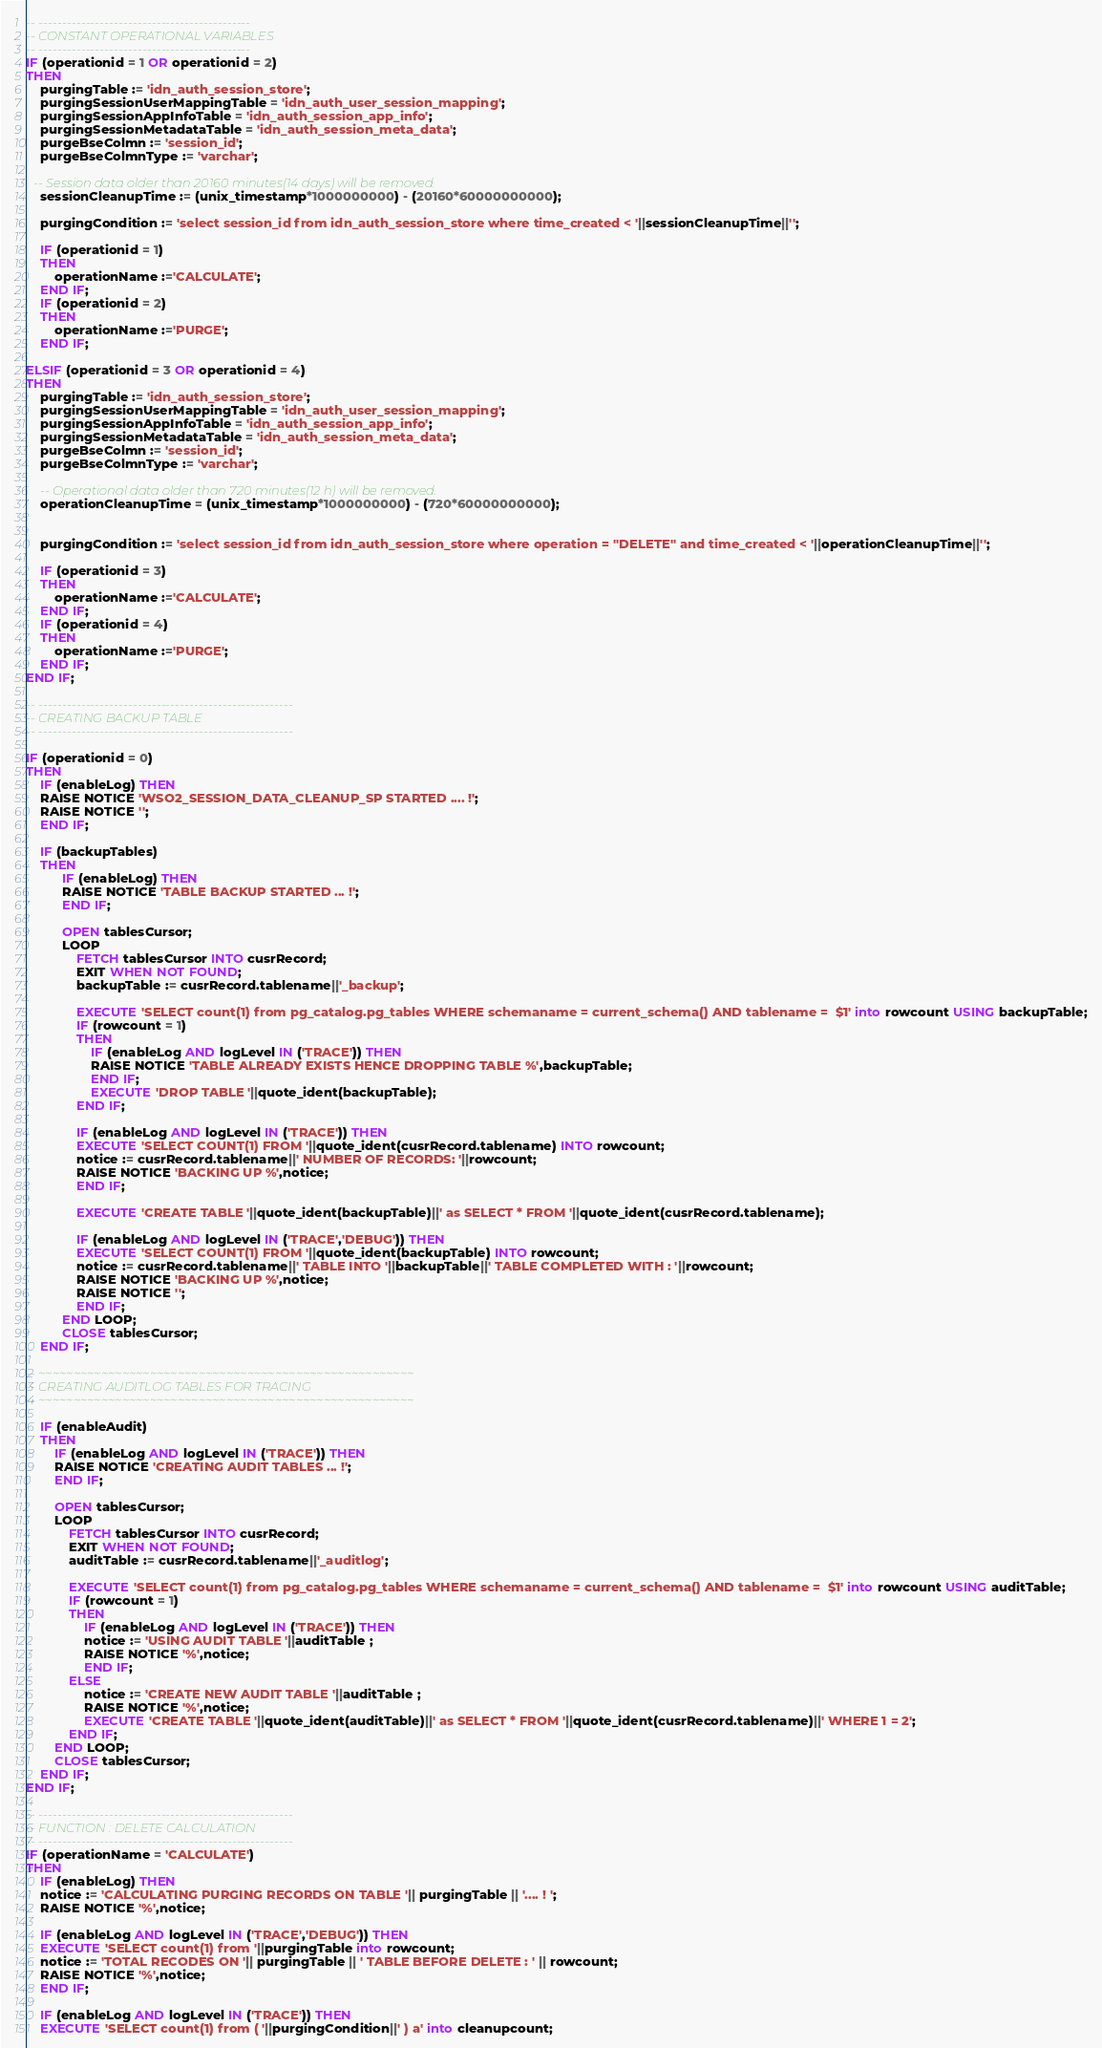<code> <loc_0><loc_0><loc_500><loc_500><_SQL_>
-- ---------------------------------------------
-- CONSTANT OPERATIONAL VARIABLES
-- ---------------------------------------------
IF (operationid = 1 OR operationid = 2)
THEN
    purgingTable := 'idn_auth_session_store';
    purgingSessionUserMappingTable = 'idn_auth_user_session_mapping';
    purgingSessionAppInfoTable = 'idn_auth_session_app_info';
    purgingSessionMetadataTable = 'idn_auth_session_meta_data';
    purgeBseColmn := 'session_id';
	purgeBseColmnType := 'varchar';

  -- Session data older than 20160 minutes(14 days) will be removed.
    sessionCleanupTime := (unix_timestamp*1000000000) - (20160*60000000000);

    purgingCondition := 'select session_id from idn_auth_session_store where time_created < '||sessionCleanupTime||'';

    IF (operationid = 1)
    THEN
        operationName :='CALCULATE';
    END IF;
    IF (operationid = 2)
    THEN
        operationName :='PURGE';
    END IF;

ELSIF (operationid = 3 OR operationid = 4)
THEN
    purgingTable := 'idn_auth_session_store';
    purgingSessionUserMappingTable = 'idn_auth_user_session_mapping';
    purgingSessionAppInfoTable = 'idn_auth_session_app_info';
    purgingSessionMetadataTable = 'idn_auth_session_meta_data';
    purgeBseColmn := 'session_id';
	purgeBseColmnType := 'varchar';

    -- Operational data older than 720 minutes(12 h) will be removed.
    operationCleanupTime = (unix_timestamp*1000000000) - (720*60000000000);


    purgingCondition := 'select session_id from idn_auth_session_store where operation = ''DELETE'' and time_created < '||operationCleanupTime||'';

    IF (operationid = 3)
    THEN
        operationName :='CALCULATE';
    END IF;
    IF (operationid = 4)
    THEN
        operationName :='PURGE';
    END IF;
END IF;

-- ------------------------------------------------------
-- CREATING BACKUP TABLE
-- ------------------------------------------------------

IF (operationid = 0)
THEN
    IF (enableLog) THEN
    RAISE NOTICE 'WSO2_SESSION_DATA_CLEANUP_SP STARTED .... !';
    RAISE NOTICE '';
    END IF;

    IF (backupTables)
    THEN
          IF (enableLog) THEN
          RAISE NOTICE 'TABLE BACKUP STARTED ... !';
          END IF;

          OPEN tablesCursor;
          LOOP
              FETCH tablesCursor INTO cusrRecord;
              EXIT WHEN NOT FOUND;
              backupTable := cusrRecord.tablename||'_backup';

              EXECUTE 'SELECT count(1) from pg_catalog.pg_tables WHERE schemaname = current_schema() AND tablename =  $1' into rowcount USING backupTable;
              IF (rowcount = 1)
              THEN
                  IF (enableLog AND logLevel IN ('TRACE')) THEN
                  RAISE NOTICE 'TABLE ALREADY EXISTS HENCE DROPPING TABLE %',backupTable;
                  END IF;
                  EXECUTE 'DROP TABLE '||quote_ident(backupTable);
              END IF;

              IF (enableLog AND logLevel IN ('TRACE')) THEN
              EXECUTE 'SELECT COUNT(1) FROM '||quote_ident(cusrRecord.tablename) INTO rowcount;
              notice := cusrRecord.tablename||' NUMBER OF RECORDS: '||rowcount;
              RAISE NOTICE 'BACKING UP %',notice;
              END IF;

              EXECUTE 'CREATE TABLE '||quote_ident(backupTable)||' as SELECT * FROM '||quote_ident(cusrRecord.tablename);

              IF (enableLog AND logLevel IN ('TRACE','DEBUG')) THEN
              EXECUTE 'SELECT COUNT(1) FROM '||quote_ident(backupTable) INTO rowcount;
              notice := cusrRecord.tablename||' TABLE INTO '||backupTable||' TABLE COMPLETED WITH : '||rowcount;
              RAISE NOTICE 'BACKING UP %',notice;
              RAISE NOTICE '';
              END IF;
          END LOOP;
          CLOSE tablesCursor;
    END IF;

-- ~~~~~~~~~~~~~~~~~~~~~~~~~~~~~~~~~~~~~~~~~~~~~~~~~~~~~~
-- CREATING AUDITLOG TABLES FOR TRACING
-- ~~~~~~~~~~~~~~~~~~~~~~~~~~~~~~~~~~~~~~~~~~~~~~~~~~~~~~

    IF (enableAudit)
    THEN
        IF (enableLog AND logLevel IN ('TRACE')) THEN
        RAISE NOTICE 'CREATING AUDIT TABLES ... !';
        END IF;

        OPEN tablesCursor;
        LOOP
            FETCH tablesCursor INTO cusrRecord;
            EXIT WHEN NOT FOUND;
            auditTable := cusrRecord.tablename||'_auditlog';

            EXECUTE 'SELECT count(1) from pg_catalog.pg_tables WHERE schemaname = current_schema() AND tablename =  $1' into rowcount USING auditTable;
            IF (rowcount = 1)
            THEN
                IF (enableLog AND logLevel IN ('TRACE')) THEN
                notice := 'USING AUDIT TABLE '||auditTable ;
                RAISE NOTICE '%',notice;
                END IF;
            ELSE
                notice := 'CREATE NEW AUDIT TABLE '||auditTable ;
                RAISE NOTICE '%',notice;
                EXECUTE 'CREATE TABLE '||quote_ident(auditTable)||' as SELECT * FROM '||quote_ident(cusrRecord.tablename)||' WHERE 1 = 2';
            END IF;
        END LOOP;
        CLOSE tablesCursor;
    END IF;
END IF;

-- ------------------------------------------------------
-- FUNCTION : DELETE CALCULATION
-- ------------------------------------------------------
IF (operationName = 'CALCULATE')
THEN
    IF (enableLog) THEN
    notice := 'CALCULATING PURGING RECORDS ON TABLE '|| purgingTable || '.... ! ';
    RAISE NOTICE '%',notice;

    IF (enableLog AND logLevel IN ('TRACE','DEBUG')) THEN
    EXECUTE 'SELECT count(1) from '||purgingTable into rowcount;
    notice := 'TOTAL RECODES ON '|| purgingTable || ' TABLE BEFORE DELETE : ' || rowcount;
    RAISE NOTICE '%',notice;
    END IF;

    IF (enableLog AND logLevel IN ('TRACE')) THEN
    EXECUTE 'SELECT count(1) from ( '||purgingCondition||' ) a' into cleanupcount;</code> 